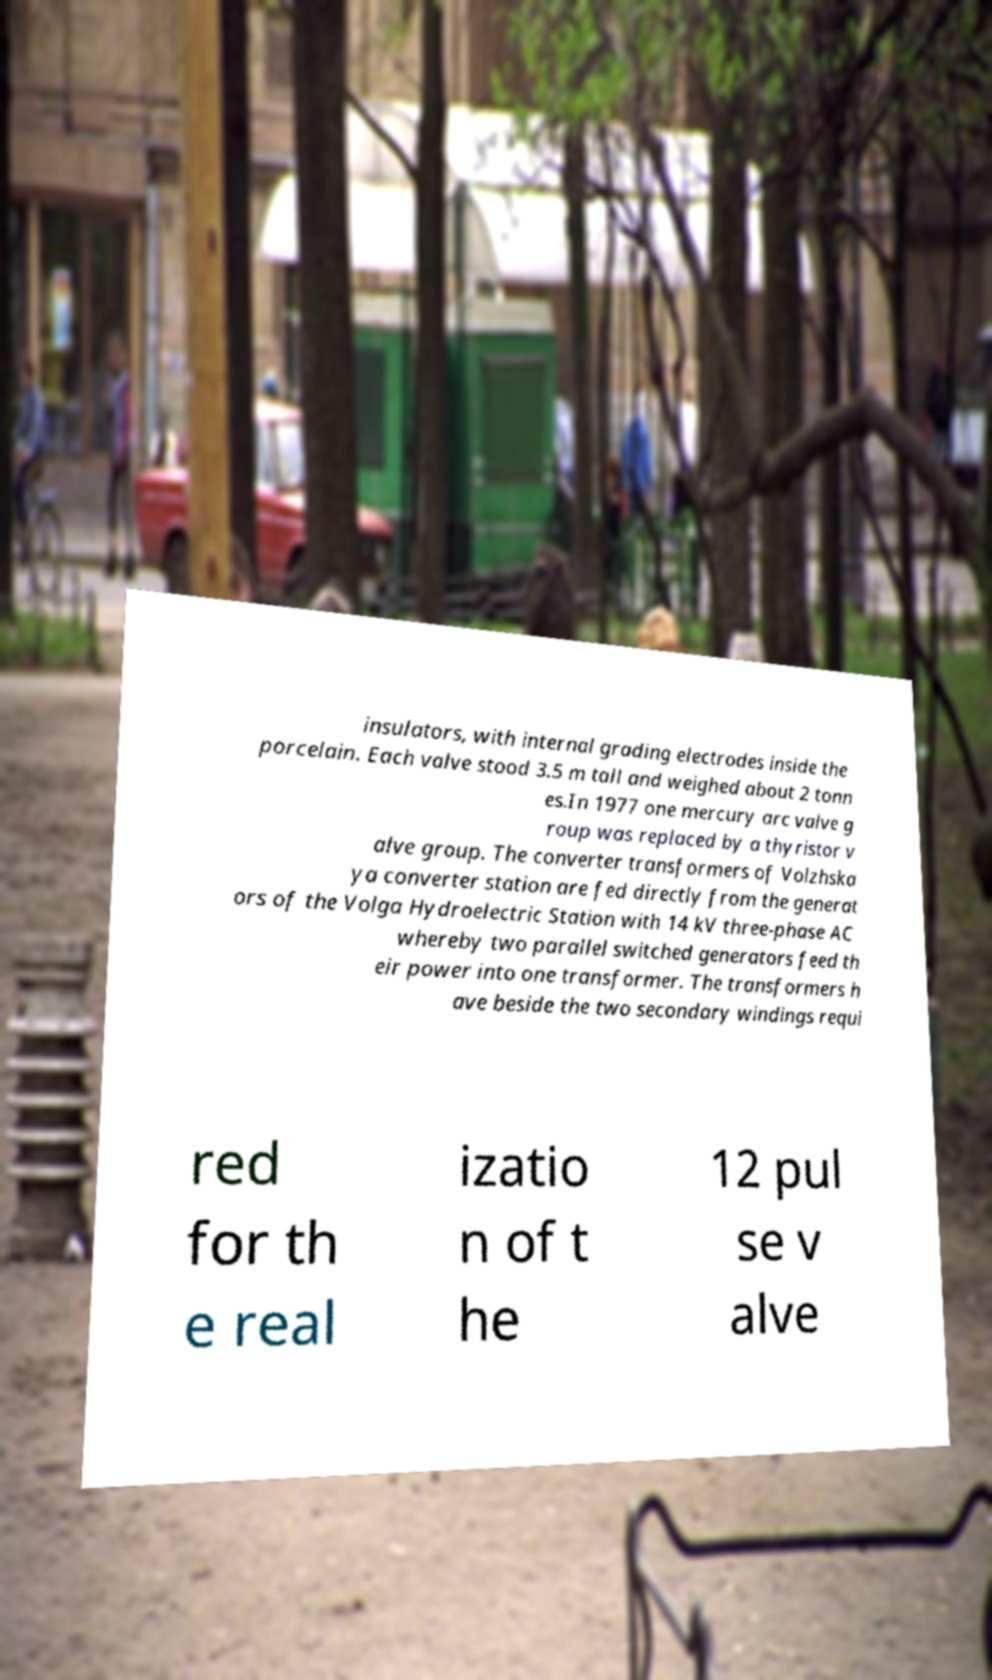Please read and relay the text visible in this image. What does it say? insulators, with internal grading electrodes inside the porcelain. Each valve stood 3.5 m tall and weighed about 2 tonn es.In 1977 one mercury arc valve g roup was replaced by a thyristor v alve group. The converter transformers of Volzhska ya converter station are fed directly from the generat ors of the Volga Hydroelectric Station with 14 kV three-phase AC whereby two parallel switched generators feed th eir power into one transformer. The transformers h ave beside the two secondary windings requi red for th e real izatio n of t he 12 pul se v alve 